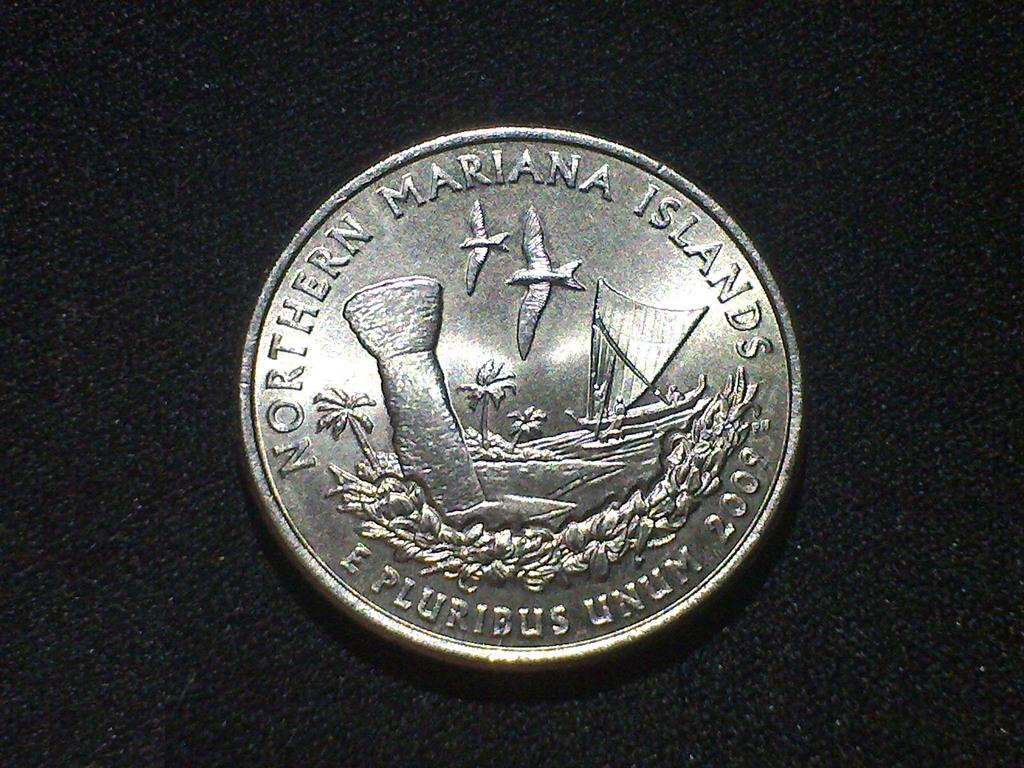Provide a one-sentence caption for the provided image. A coin reading "Northern Mariana Islands" on a black surface. 